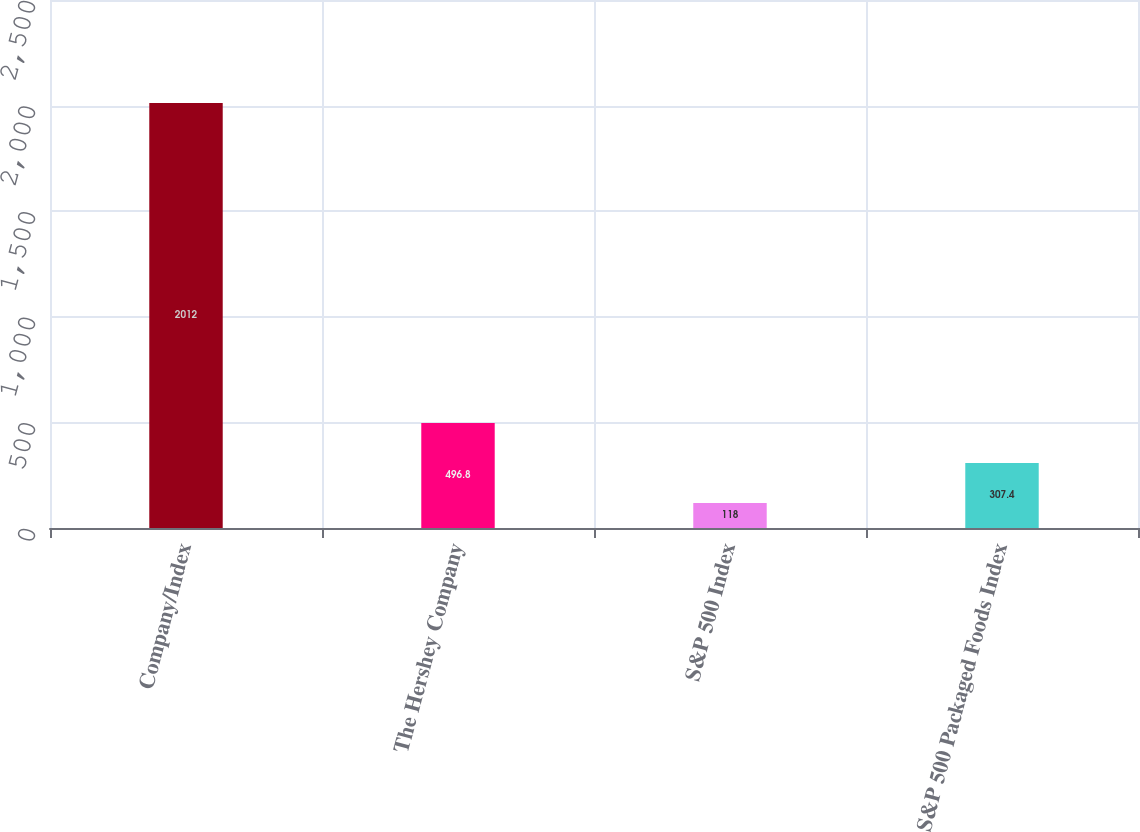Convert chart to OTSL. <chart><loc_0><loc_0><loc_500><loc_500><bar_chart><fcel>Company/Index<fcel>The Hershey Company<fcel>S&P 500 Index<fcel>S&P 500 Packaged Foods Index<nl><fcel>2012<fcel>496.8<fcel>118<fcel>307.4<nl></chart> 